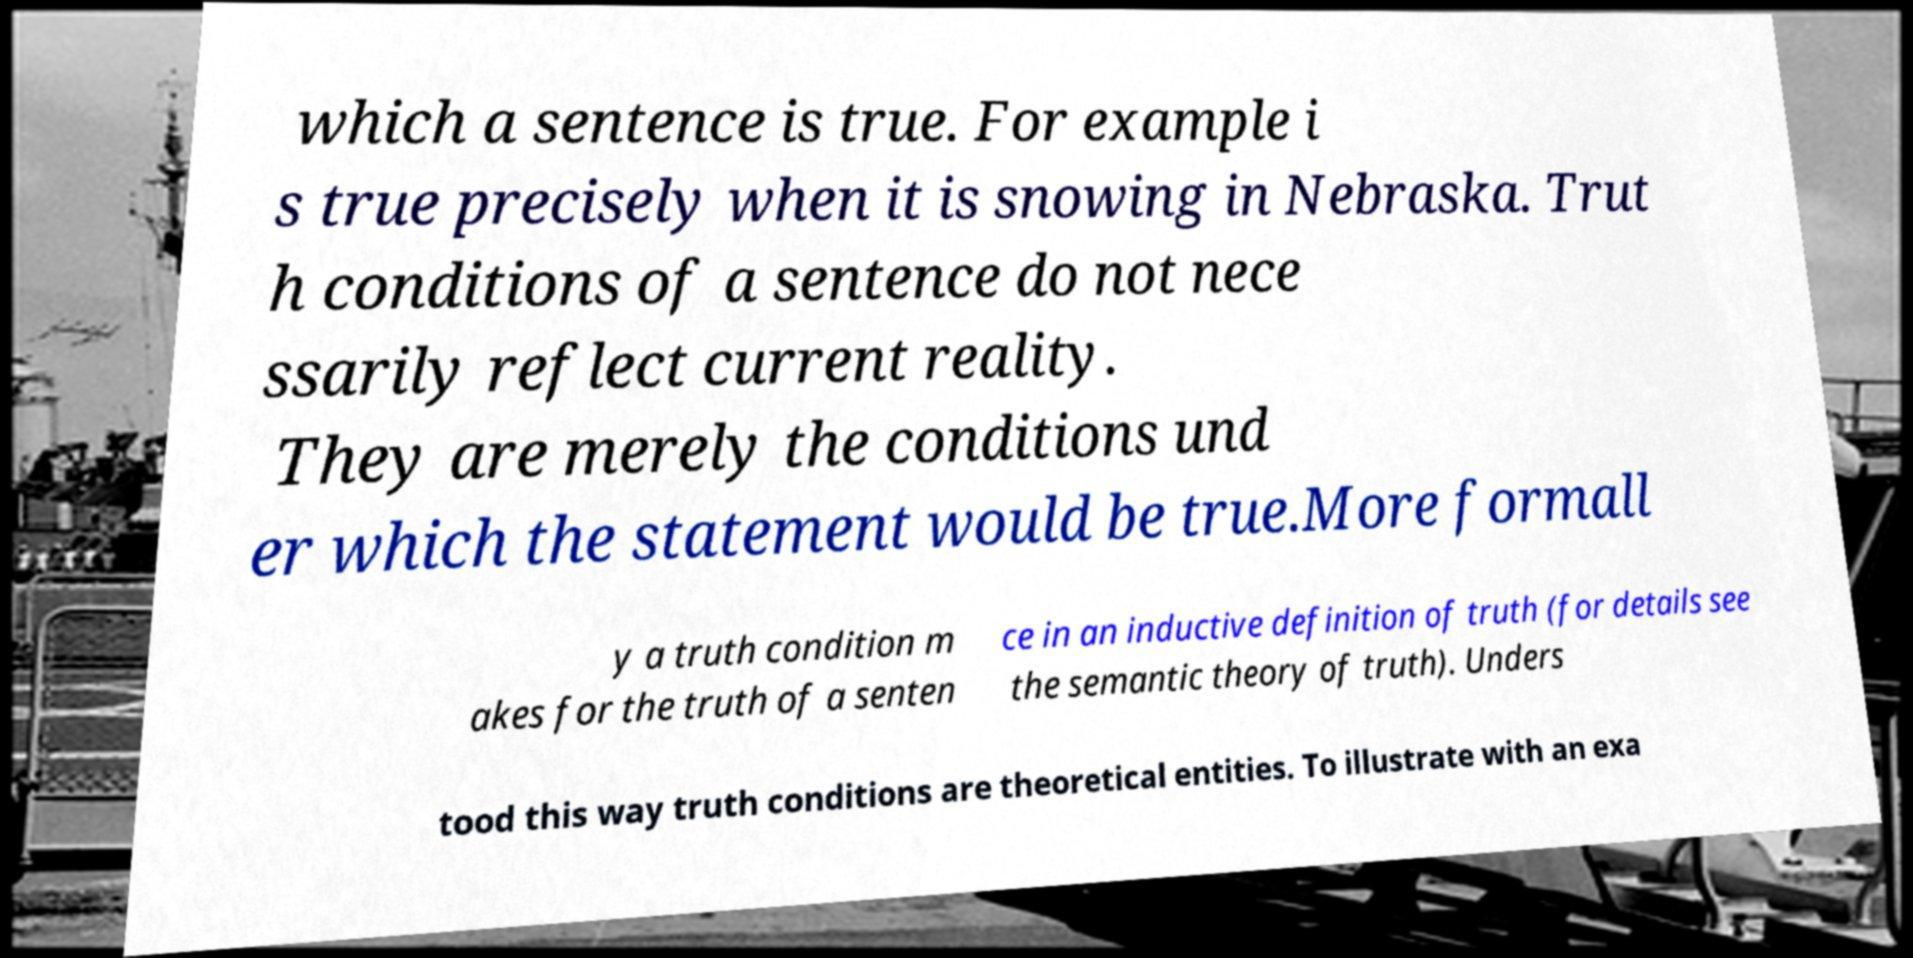There's text embedded in this image that I need extracted. Can you transcribe it verbatim? which a sentence is true. For example i s true precisely when it is snowing in Nebraska. Trut h conditions of a sentence do not nece ssarily reflect current reality. They are merely the conditions und er which the statement would be true.More formall y a truth condition m akes for the truth of a senten ce in an inductive definition of truth (for details see the semantic theory of truth). Unders tood this way truth conditions are theoretical entities. To illustrate with an exa 